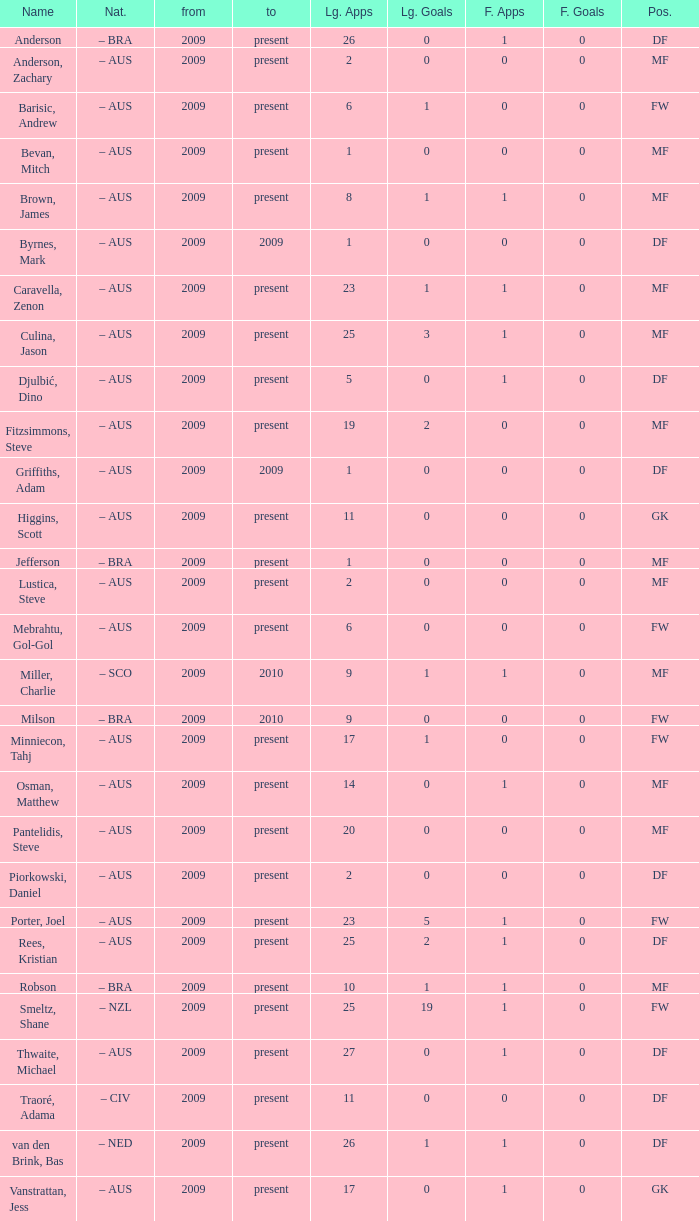Name the position for van den brink, bas DF. 